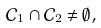Convert formula to latex. <formula><loc_0><loc_0><loc_500><loc_500>\mathcal { C } _ { 1 } \cap \mathcal { C } _ { 2 } \ne \emptyset ,</formula> 